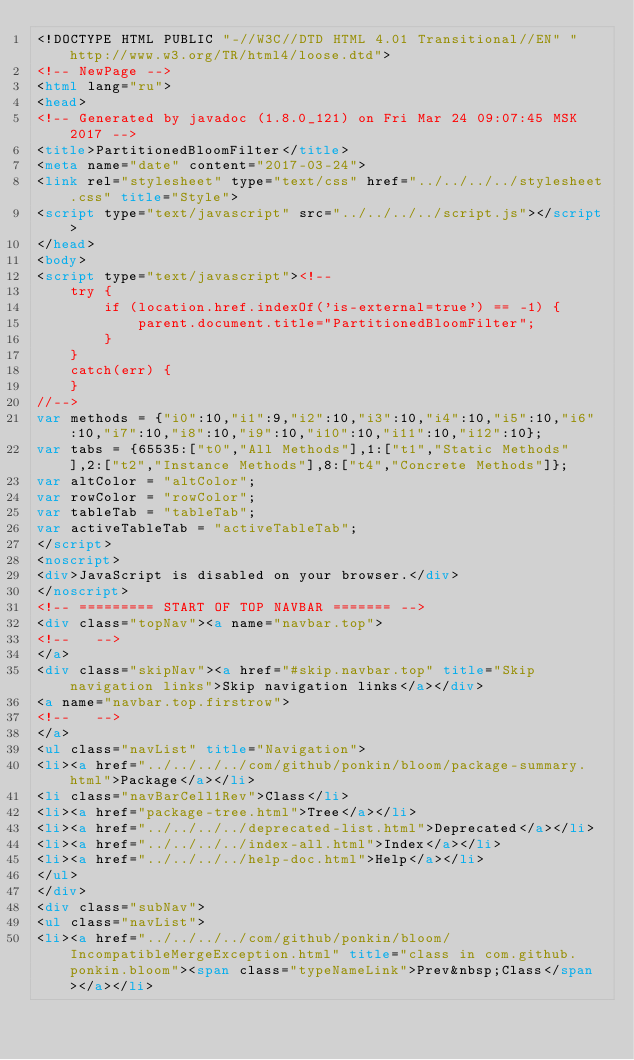Convert code to text. <code><loc_0><loc_0><loc_500><loc_500><_HTML_><!DOCTYPE HTML PUBLIC "-//W3C//DTD HTML 4.01 Transitional//EN" "http://www.w3.org/TR/html4/loose.dtd">
<!-- NewPage -->
<html lang="ru">
<head>
<!-- Generated by javadoc (1.8.0_121) on Fri Mar 24 09:07:45 MSK 2017 -->
<title>PartitionedBloomFilter</title>
<meta name="date" content="2017-03-24">
<link rel="stylesheet" type="text/css" href="../../../../stylesheet.css" title="Style">
<script type="text/javascript" src="../../../../script.js"></script>
</head>
<body>
<script type="text/javascript"><!--
    try {
        if (location.href.indexOf('is-external=true') == -1) {
            parent.document.title="PartitionedBloomFilter";
        }
    }
    catch(err) {
    }
//-->
var methods = {"i0":10,"i1":9,"i2":10,"i3":10,"i4":10,"i5":10,"i6":10,"i7":10,"i8":10,"i9":10,"i10":10,"i11":10,"i12":10};
var tabs = {65535:["t0","All Methods"],1:["t1","Static Methods"],2:["t2","Instance Methods"],8:["t4","Concrete Methods"]};
var altColor = "altColor";
var rowColor = "rowColor";
var tableTab = "tableTab";
var activeTableTab = "activeTableTab";
</script>
<noscript>
<div>JavaScript is disabled on your browser.</div>
</noscript>
<!-- ========= START OF TOP NAVBAR ======= -->
<div class="topNav"><a name="navbar.top">
<!--   -->
</a>
<div class="skipNav"><a href="#skip.navbar.top" title="Skip navigation links">Skip navigation links</a></div>
<a name="navbar.top.firstrow">
<!--   -->
</a>
<ul class="navList" title="Navigation">
<li><a href="../../../../com/github/ponkin/bloom/package-summary.html">Package</a></li>
<li class="navBarCell1Rev">Class</li>
<li><a href="package-tree.html">Tree</a></li>
<li><a href="../../../../deprecated-list.html">Deprecated</a></li>
<li><a href="../../../../index-all.html">Index</a></li>
<li><a href="../../../../help-doc.html">Help</a></li>
</ul>
</div>
<div class="subNav">
<ul class="navList">
<li><a href="../../../../com/github/ponkin/bloom/IncompatibleMergeException.html" title="class in com.github.ponkin.bloom"><span class="typeNameLink">Prev&nbsp;Class</span></a></li></code> 